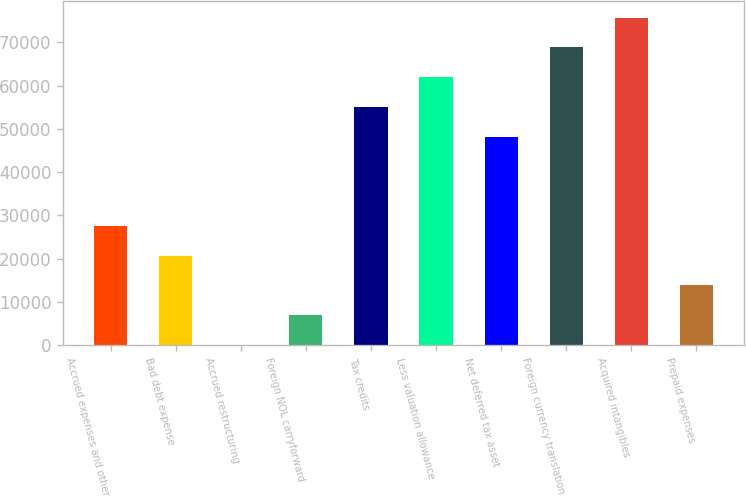Convert chart. <chart><loc_0><loc_0><loc_500><loc_500><bar_chart><fcel>Accrued expenses and other<fcel>Bad debt expense<fcel>Accrued restructuring<fcel>Foreign NOL carryforward<fcel>Tax credits<fcel>Less valuation allowance<fcel>Net deferred tax asset<fcel>Foreign currency translation<fcel>Acquired intangibles<fcel>Prepaid expenses<nl><fcel>27539.2<fcel>20663.9<fcel>38<fcel>6913.3<fcel>55040.4<fcel>61915.7<fcel>48165.1<fcel>68791<fcel>75666.3<fcel>13788.6<nl></chart> 